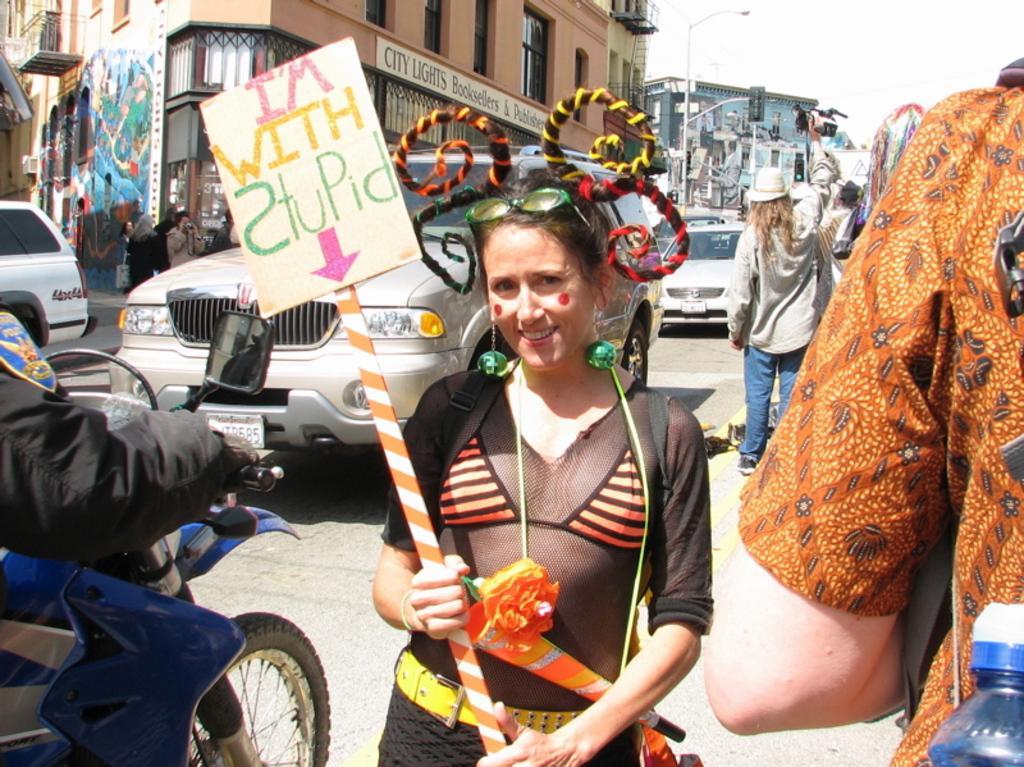Describe this image in one or two sentences. This image is taken outdoors. At the top of the image there is a sky with clouds. In the background there are a few buildings and there are a few boards with text on them. There is a street light. At the bottom of the image there is a road. In the middle of the image a few cars are moving on the road. A few people are walking on the road and a few are standing. A woman is standing on the road and she is holding a placard with a text on it. On the right side of the image there is a man. On the left side of the image a man is riding on the bike. 